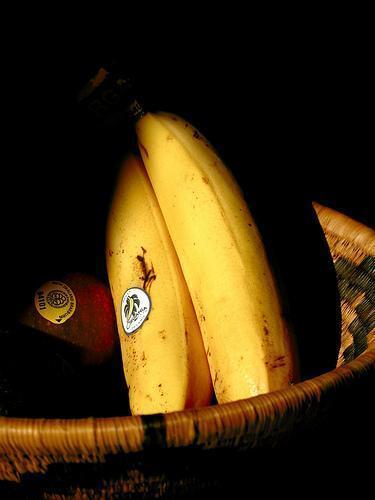How many apples in the basket?
Give a very brief answer. 1. 